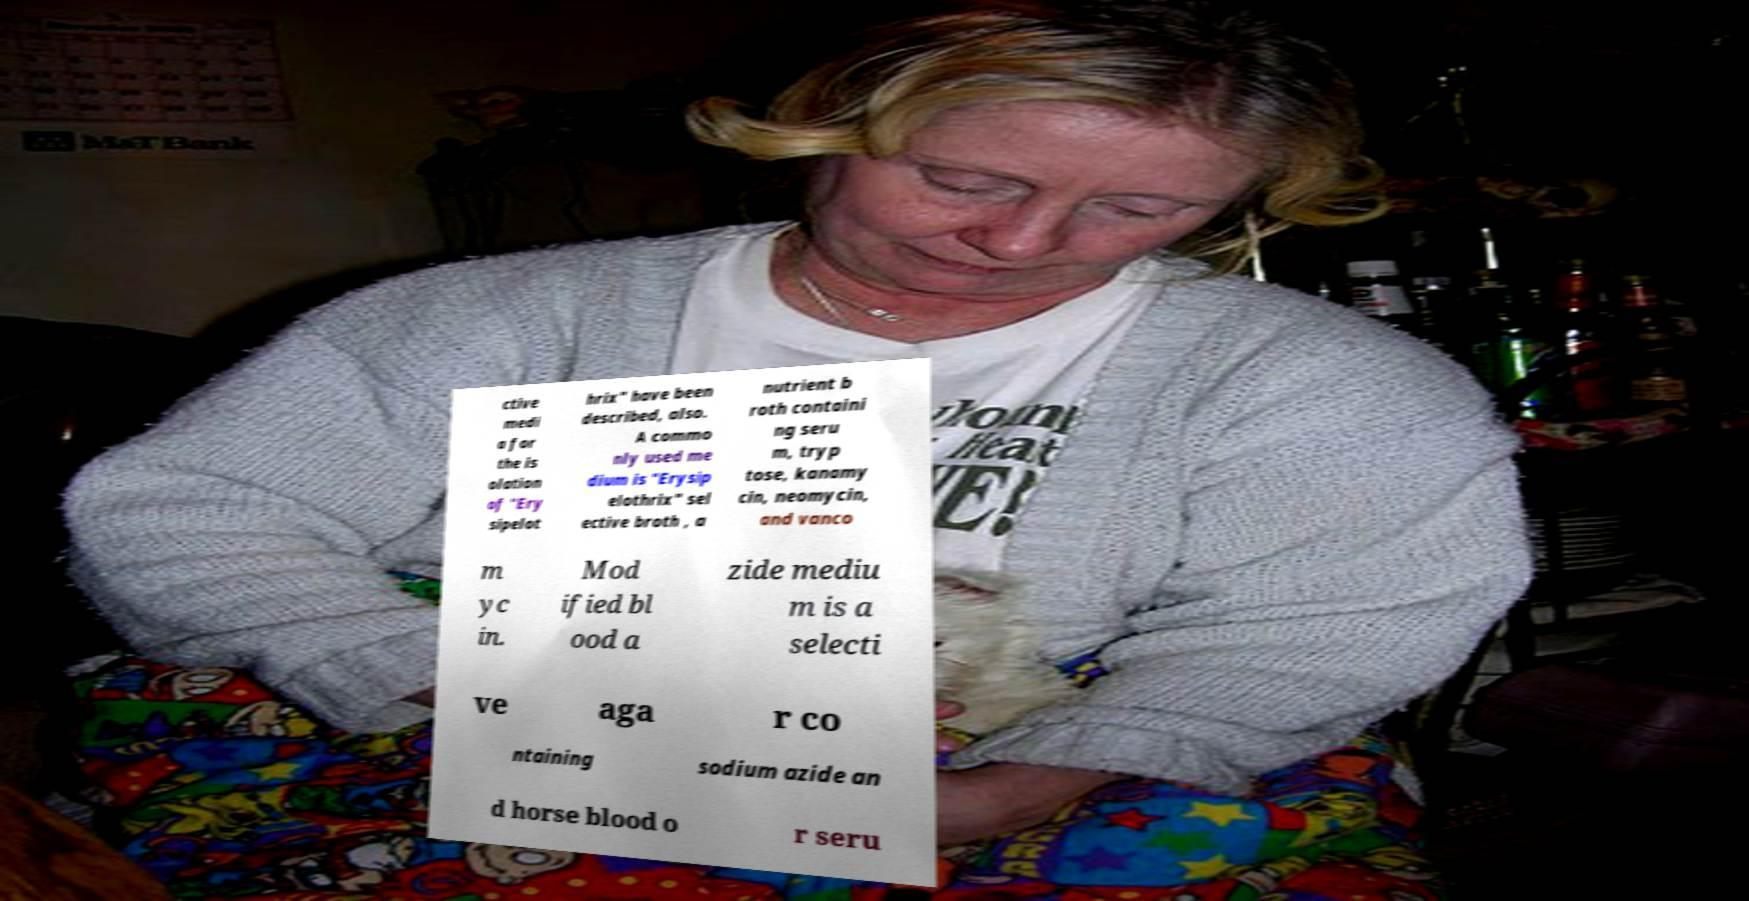Can you accurately transcribe the text from the provided image for me? ctive medi a for the is olation of "Ery sipelot hrix" have been described, also. A commo nly used me dium is "Erysip elothrix" sel ective broth , a nutrient b roth containi ng seru m, tryp tose, kanamy cin, neomycin, and vanco m yc in. Mod ified bl ood a zide mediu m is a selecti ve aga r co ntaining sodium azide an d horse blood o r seru 